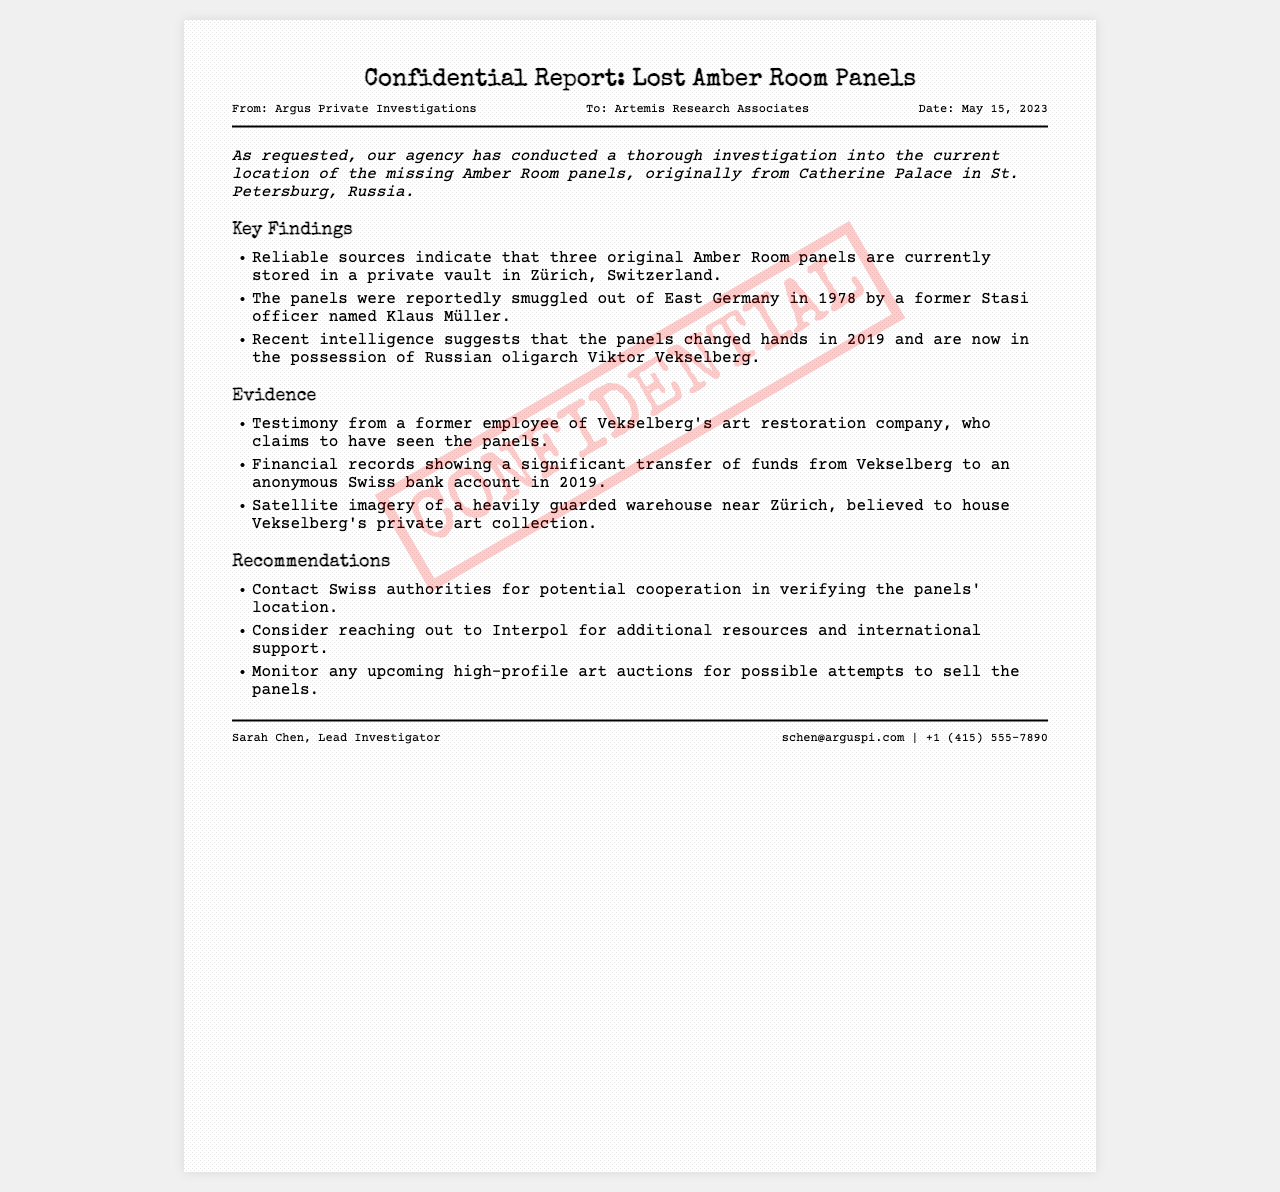What is the title of the report? The title of the report is stated at the top of the document.
Answer: Confidential Report: Lost Amber Room Panels Who conducted the investigation? The agency that conducted the investigation is mentioned in the header details.
Answer: Argus Private Investigations To whom is the report addressed? The recipient of the report is indicated in the header details.
Answer: Artemis Research Associates What date was the report sent? The date on which the report was created is provided in the header details.
Answer: May 15, 2023 How many original Amber Room panels are believed to be in Zürich? The document specifies the number of panels located in Zürich in the key findings section.
Answer: three Who is the former Stasi officer mentioned? The document identifies the person who smuggled the panels out of East Germany.
Answer: Klaus Müller What notable individual currently possesses the panels? The document mentions the individual who has possession of the panels in the key findings.
Answer: Viktor Vekselberg What does the report recommend contacting for verification? The recommendations section includes a suggestion for an organization to contact for cooperation.
Answer: Swiss authorities Who is the lead investigator of the report? The footer of the document includes the name of the lead investigator.
Answer: Sarah Chen 